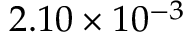Convert formula to latex. <formula><loc_0><loc_0><loc_500><loc_500>2 . 1 0 \times 1 0 ^ { - 3 }</formula> 